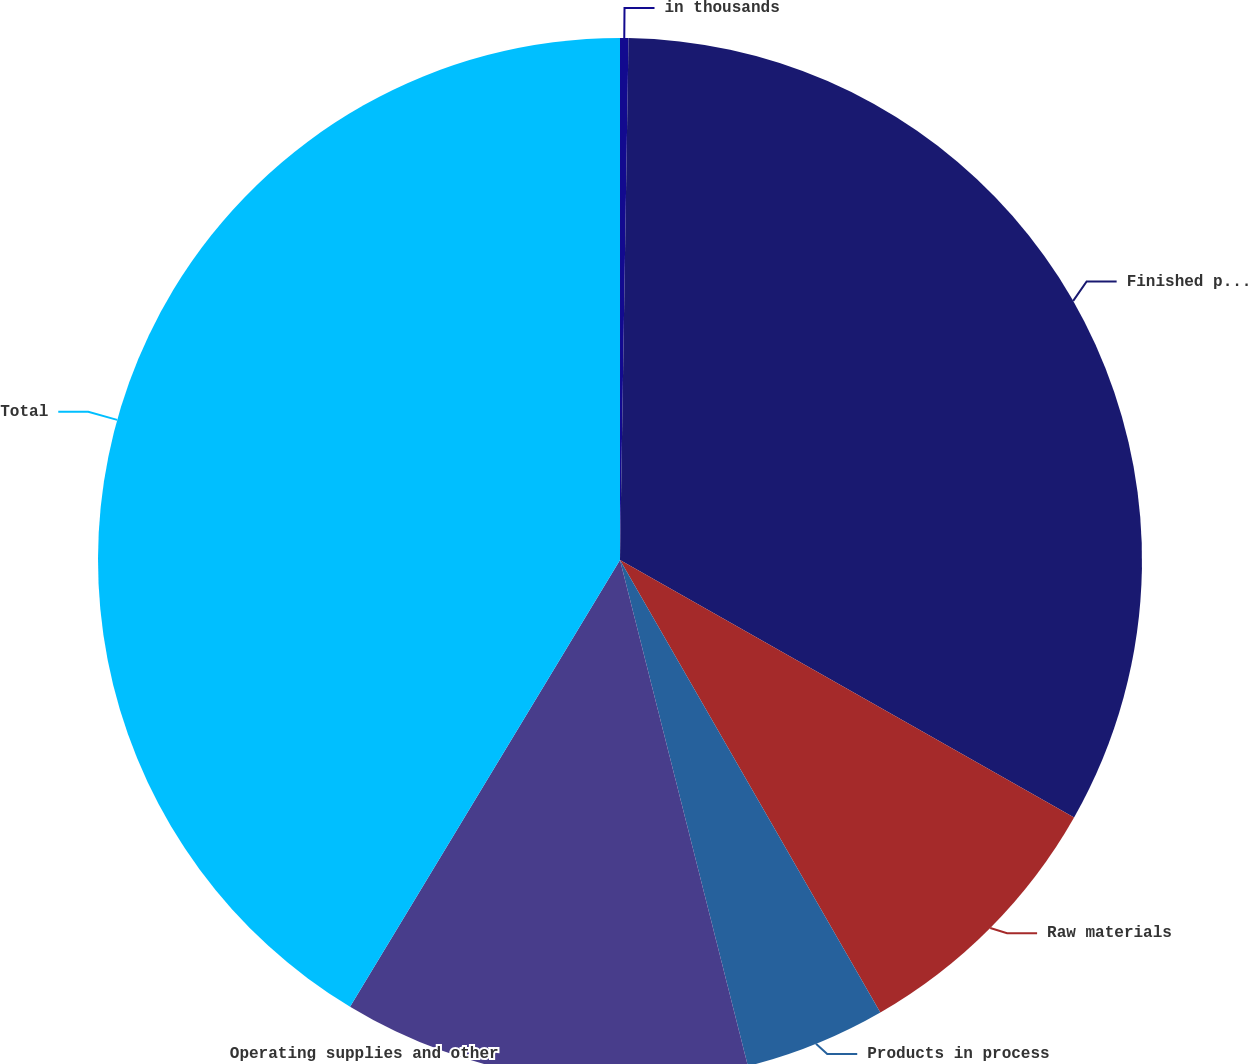<chart> <loc_0><loc_0><loc_500><loc_500><pie_chart><fcel>in thousands<fcel>Finished products<fcel>Raw materials<fcel>Products in process<fcel>Operating supplies and other<fcel>Total<nl><fcel>0.26%<fcel>32.95%<fcel>8.48%<fcel>4.37%<fcel>12.59%<fcel>41.35%<nl></chart> 